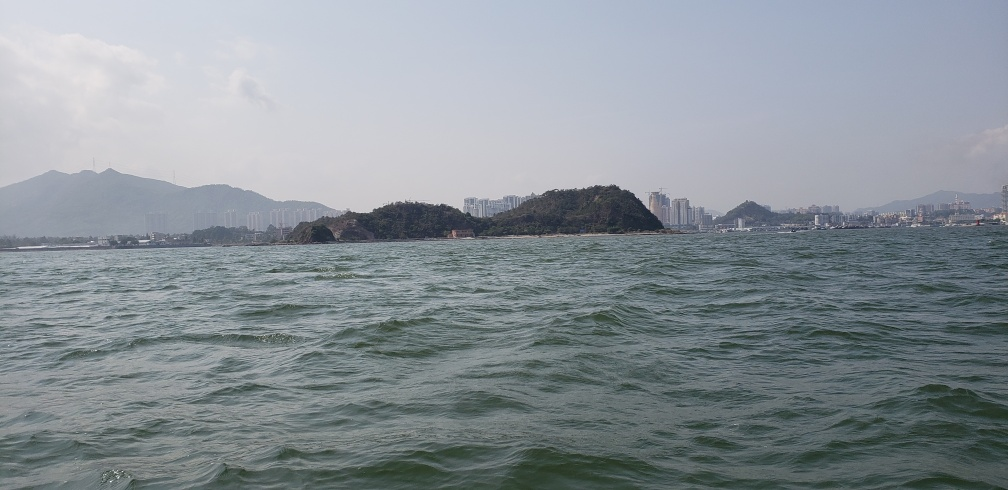What time of day does this photo appear to be taken? The photo seems to be taken during midday, indicated by the bright and clear sky. The sunlight is fairly intense, casting mild glares on the water's surface and lighting the scene uniformly without long shadows that would suggest early morning or late afternoon. Is there any sign of human activity visible in this image? Yes, there are several indications of human activity. For one, there are buildings visible on the shoreline and the hillside. Additionally, the water's choppiness could be due to boats, suggesting recent boat traffic even though no boats are immediately visible in the frame. 